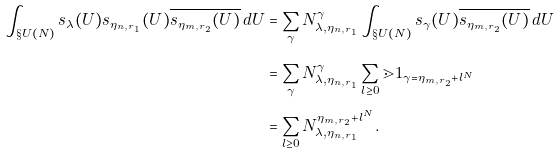Convert formula to latex. <formula><loc_0><loc_0><loc_500><loc_500>\int _ { \S U ( N ) } s _ { \lambda } ( U ) s _ { \eta _ { n , r _ { 1 } } } ( U ) \overline { s _ { \eta _ { m , r _ { 2 } } } ( U ) } \, d U & = \sum _ { \gamma } N _ { \lambda , \eta _ { n , r _ { 1 } } } ^ { \gamma } \int _ { \S U ( N ) } s _ { \gamma } ( U ) \overline { s _ { \eta _ { m , r _ { 2 } } } ( U ) } \, d U \\ & = \sum _ { \gamma } N _ { \lambda , \eta _ { n , r _ { 1 } } } ^ { \gamma } \sum _ { l \geq 0 } { \mathbb { m } 1 } _ { \gamma = \eta _ { m , r _ { 2 } } + l ^ { N } } \\ & = \sum _ { l \geq 0 } N _ { \lambda , \eta _ { n , r _ { 1 } } } ^ { \eta _ { m , r _ { 2 } } + l ^ { N } } .</formula> 